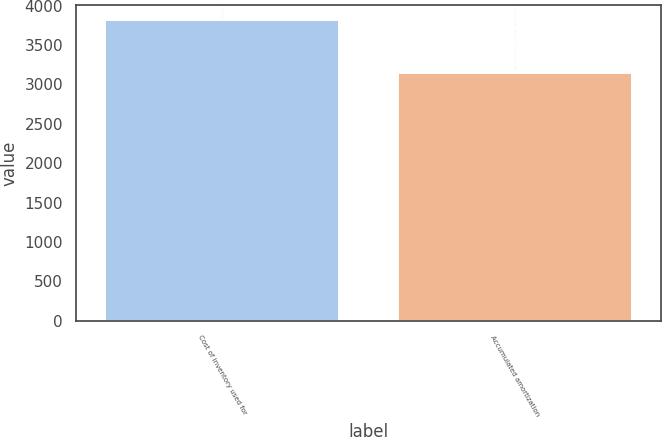Convert chart to OTSL. <chart><loc_0><loc_0><loc_500><loc_500><bar_chart><fcel>Cost of inventory used for<fcel>Accumulated amortization<nl><fcel>3815<fcel>3148<nl></chart> 